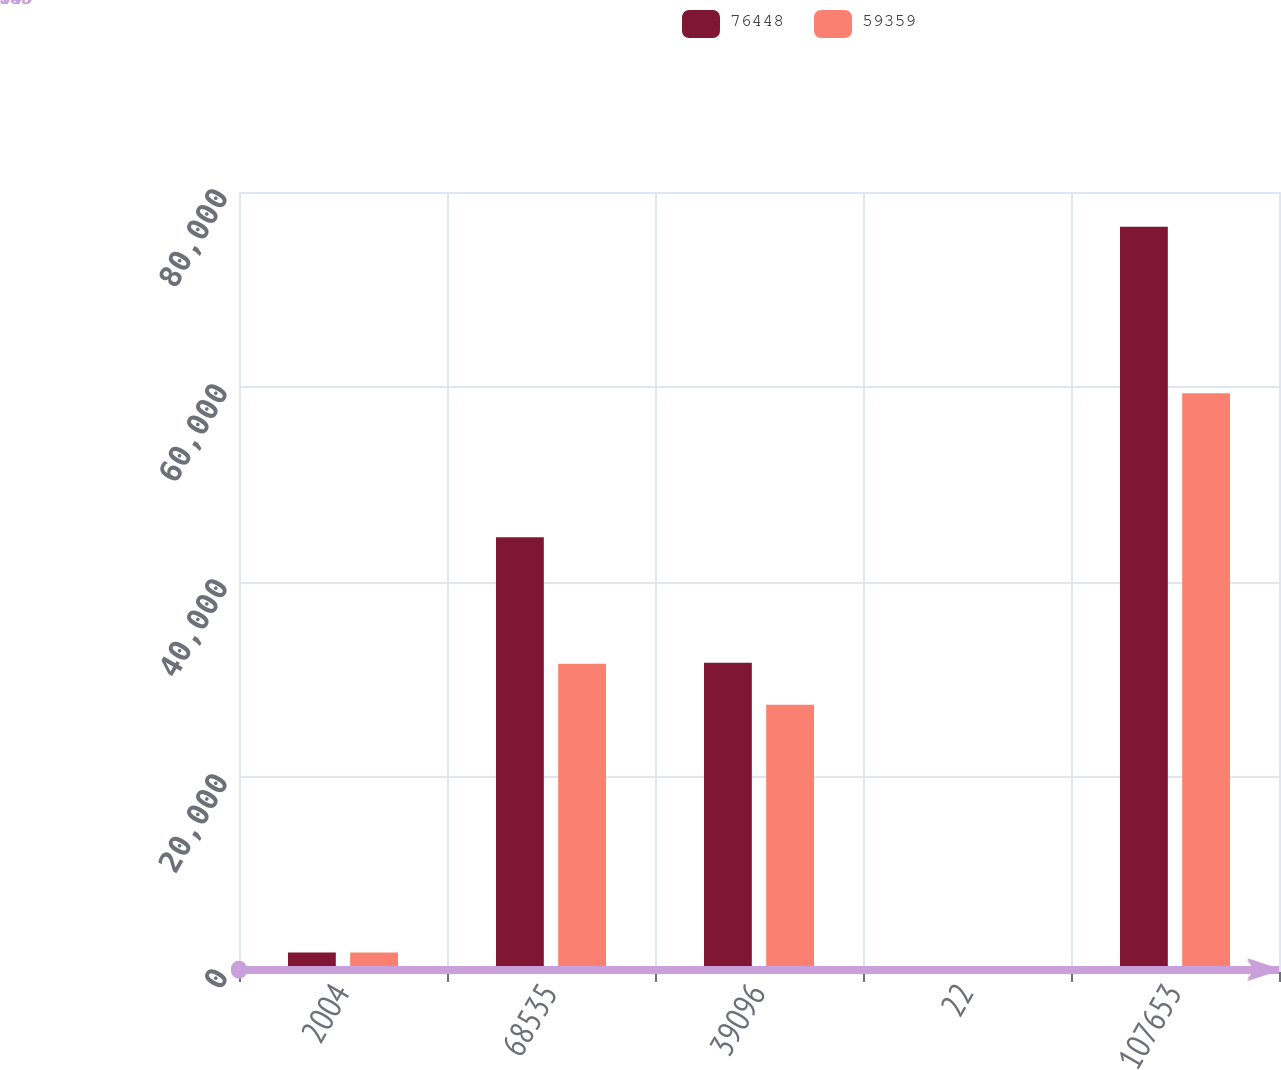Convert chart. <chart><loc_0><loc_0><loc_500><loc_500><stacked_bar_chart><ecel><fcel>2004<fcel>68535<fcel>39096<fcel>22<fcel>107653<nl><fcel>76448<fcel>2003<fcel>44602<fcel>31711<fcel>135<fcel>76448<nl><fcel>59359<fcel>2002<fcel>31616<fcel>27398<fcel>345<fcel>59359<nl></chart> 